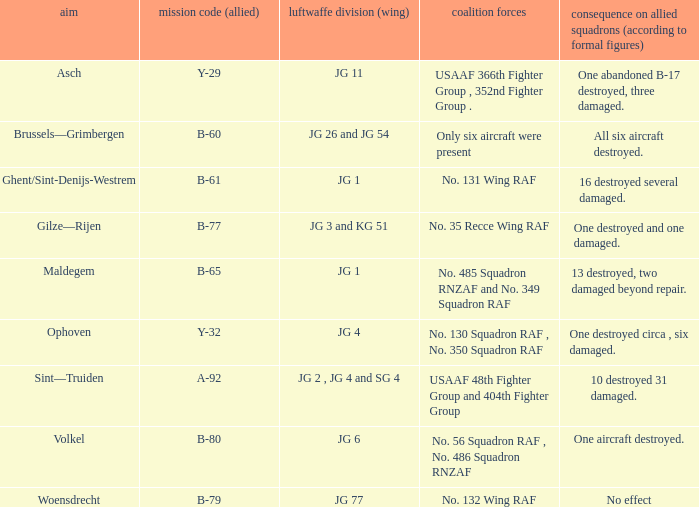Which Allied Force targetted Woensdrecht? No. 132 Wing RAF. 